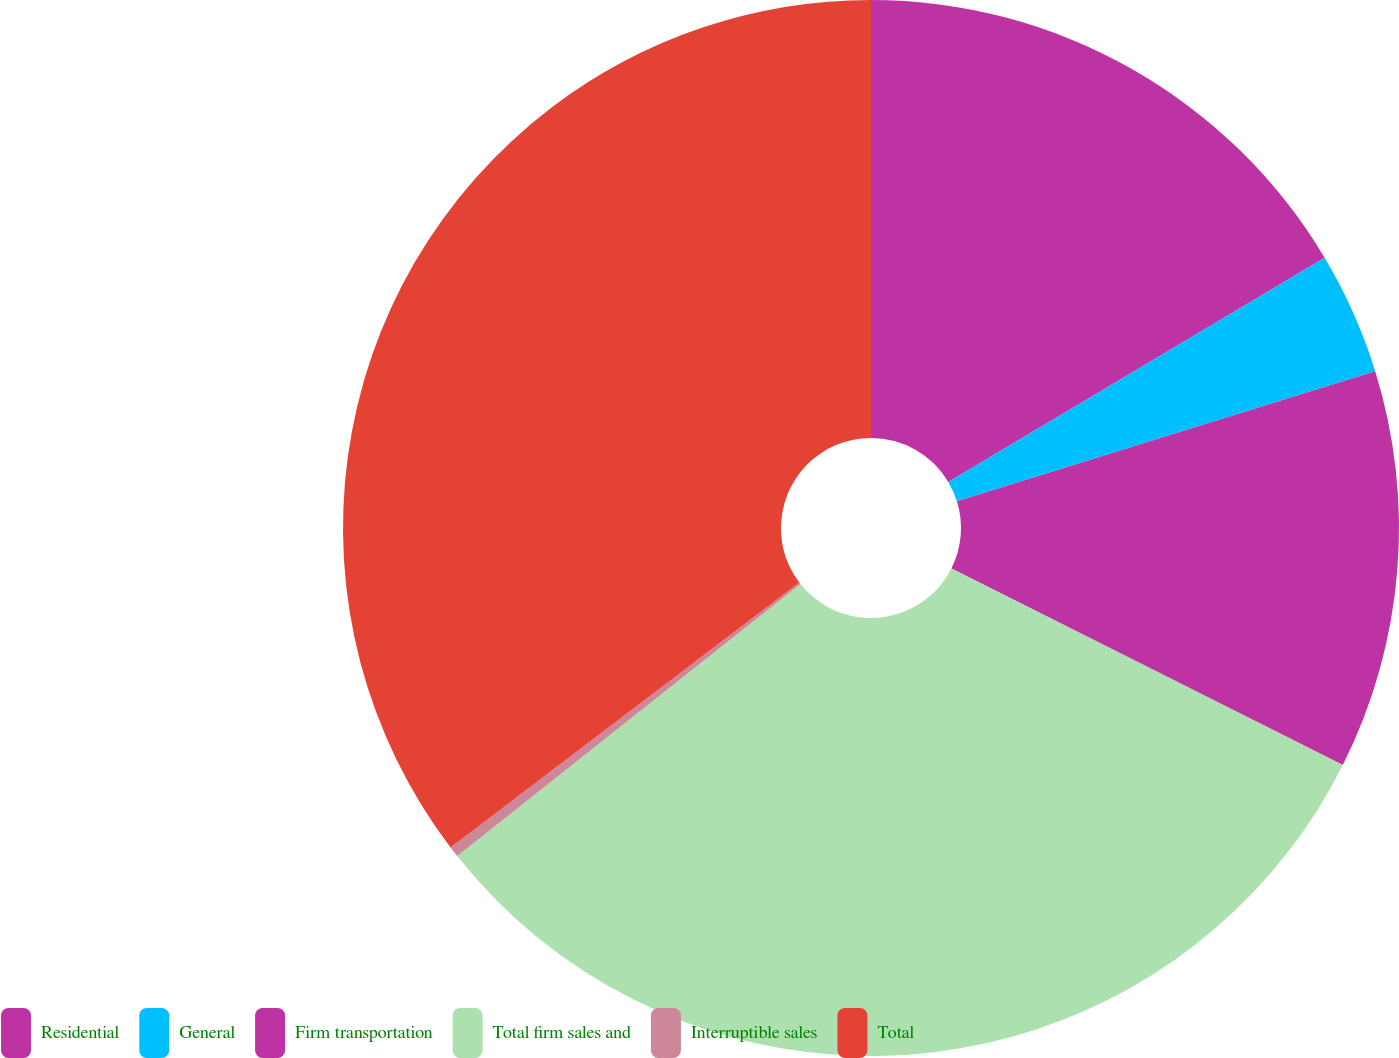<chart> <loc_0><loc_0><loc_500><loc_500><pie_chart><fcel>Residential<fcel>General<fcel>Firm transportation<fcel>Total firm sales and<fcel>Interruptible sales<fcel>Total<nl><fcel>16.45%<fcel>3.75%<fcel>12.21%<fcel>31.92%<fcel>0.33%<fcel>35.34%<nl></chart> 